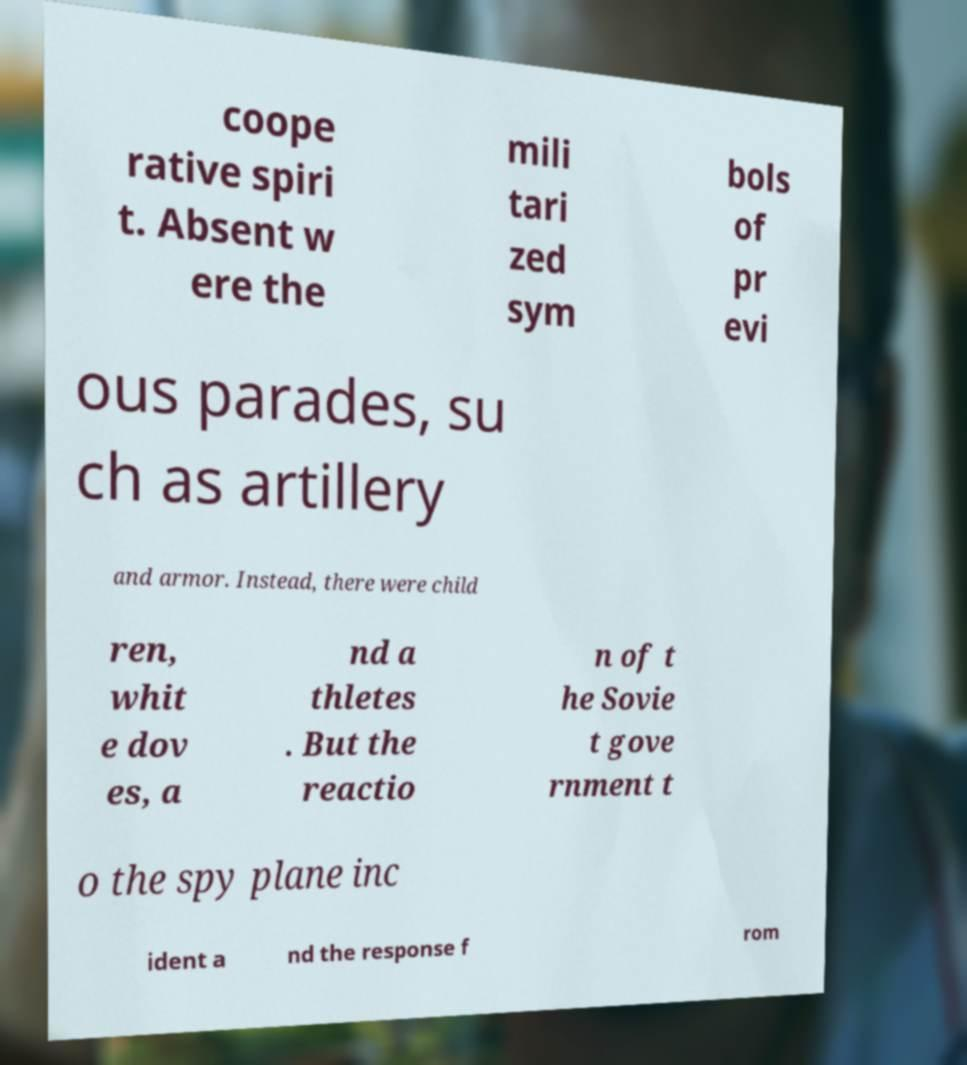What messages or text are displayed in this image? I need them in a readable, typed format. coope rative spiri t. Absent w ere the mili tari zed sym bols of pr evi ous parades, su ch as artillery and armor. Instead, there were child ren, whit e dov es, a nd a thletes . But the reactio n of t he Sovie t gove rnment t o the spy plane inc ident a nd the response f rom 